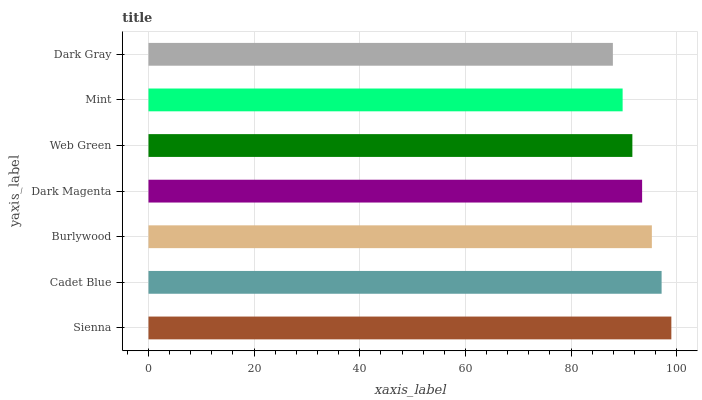Is Dark Gray the minimum?
Answer yes or no. Yes. Is Sienna the maximum?
Answer yes or no. Yes. Is Cadet Blue the minimum?
Answer yes or no. No. Is Cadet Blue the maximum?
Answer yes or no. No. Is Sienna greater than Cadet Blue?
Answer yes or no. Yes. Is Cadet Blue less than Sienna?
Answer yes or no. Yes. Is Cadet Blue greater than Sienna?
Answer yes or no. No. Is Sienna less than Cadet Blue?
Answer yes or no. No. Is Dark Magenta the high median?
Answer yes or no. Yes. Is Dark Magenta the low median?
Answer yes or no. Yes. Is Dark Gray the high median?
Answer yes or no. No. Is Burlywood the low median?
Answer yes or no. No. 